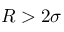<formula> <loc_0><loc_0><loc_500><loc_500>R > 2 \sigma</formula> 